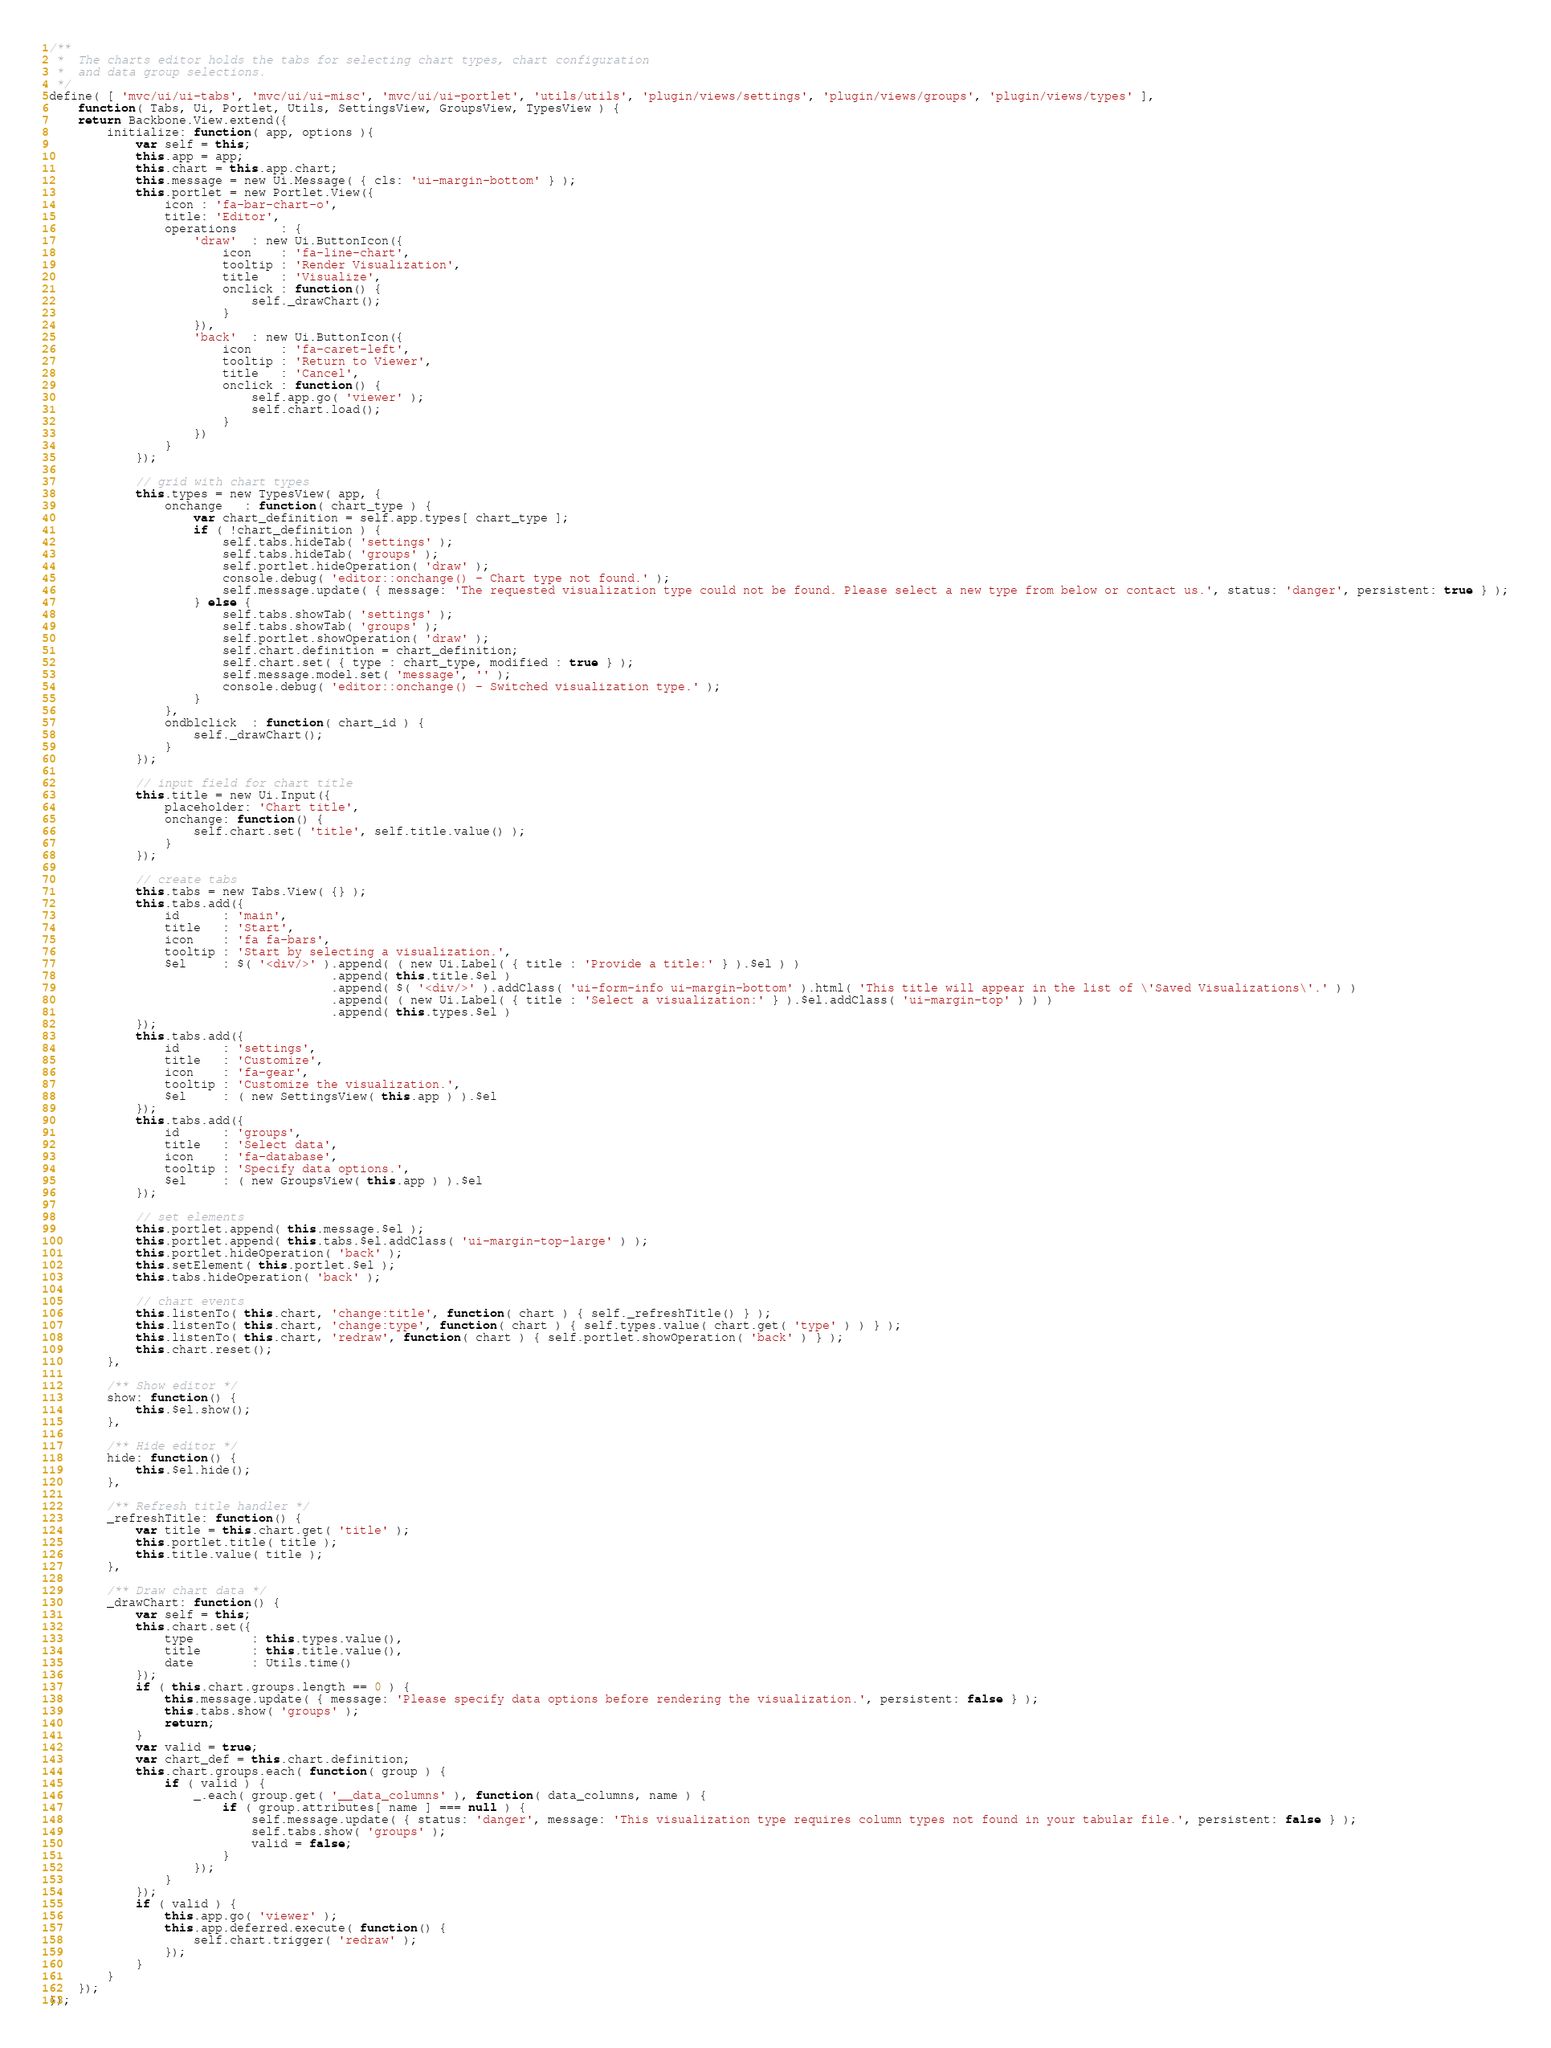<code> <loc_0><loc_0><loc_500><loc_500><_JavaScript_>/**
 *  The charts editor holds the tabs for selecting chart types, chart configuration
 *  and data group selections.
 */
define( [ 'mvc/ui/ui-tabs', 'mvc/ui/ui-misc', 'mvc/ui/ui-portlet', 'utils/utils', 'plugin/views/settings', 'plugin/views/groups', 'plugin/views/types' ],
    function( Tabs, Ui, Portlet, Utils, SettingsView, GroupsView, TypesView ) {
    return Backbone.View.extend({
        initialize: function( app, options ){
            var self = this;
            this.app = app;
            this.chart = this.app.chart;
            this.message = new Ui.Message( { cls: 'ui-margin-bottom' } );
            this.portlet = new Portlet.View({
                icon : 'fa-bar-chart-o',
                title: 'Editor',
                operations      : {
                    'draw'  : new Ui.ButtonIcon({
                        icon    : 'fa-line-chart',
                        tooltip : 'Render Visualization',
                        title   : 'Visualize',
                        onclick : function() {
                            self._drawChart();
                        }
                    }),
                    'back'  : new Ui.ButtonIcon({
                        icon    : 'fa-caret-left',
                        tooltip : 'Return to Viewer',
                        title   : 'Cancel',
                        onclick : function() {
                            self.app.go( 'viewer' );
                            self.chart.load();
                        }
                    })
                }
            });

            // grid with chart types
            this.types = new TypesView( app, {
                onchange   : function( chart_type ) {
                    var chart_definition = self.app.types[ chart_type ];
                    if ( !chart_definition ) {
                        self.tabs.hideTab( 'settings' );
                        self.tabs.hideTab( 'groups' );
                        self.portlet.hideOperation( 'draw' );
                        console.debug( 'editor::onchange() - Chart type not found.' );
                        self.message.update( { message: 'The requested visualization type could not be found. Please select a new type from below or contact us.', status: 'danger', persistent: true } );
                    } else {
                        self.tabs.showTab( 'settings' );
                        self.tabs.showTab( 'groups' );
                        self.portlet.showOperation( 'draw' );
                        self.chart.definition = chart_definition;
                        self.chart.set( { type : chart_type, modified : true } );
                        self.message.model.set( 'message', '' );
                        console.debug( 'editor::onchange() - Switched visualization type.' );
                    }
                },
                ondblclick  : function( chart_id ) {
                    self._drawChart();
                }
            });

            // input field for chart title
            this.title = new Ui.Input({
                placeholder: 'Chart title',
                onchange: function() {
                    self.chart.set( 'title', self.title.value() );
                }
            });

            // create tabs
            this.tabs = new Tabs.View( {} );
            this.tabs.add({
                id      : 'main',
                title   : 'Start',
                icon    : 'fa fa-bars',
                tooltip : 'Start by selecting a visualization.',
                $el     : $( '<div/>' ).append( ( new Ui.Label( { title : 'Provide a title:' } ).$el ) )
                                       .append( this.title.$el )
                                       .append( $( '<div/>' ).addClass( 'ui-form-info ui-margin-bottom' ).html( 'This title will appear in the list of \'Saved Visualizations\'.' ) )
                                       .append( ( new Ui.Label( { title : 'Select a visualization:' } ).$el.addClass( 'ui-margin-top' ) ) )
                                       .append( this.types.$el )
            });
            this.tabs.add({
                id      : 'settings',
                title   : 'Customize',
                icon    : 'fa-gear',
                tooltip : 'Customize the visualization.',
                $el     : ( new SettingsView( this.app ) ).$el
            });
            this.tabs.add({
                id      : 'groups',
                title   : 'Select data',
                icon    : 'fa-database',
                tooltip : 'Specify data options.',
                $el     : ( new GroupsView( this.app ) ).$el
            });

            // set elements
            this.portlet.append( this.message.$el );
            this.portlet.append( this.tabs.$el.addClass( 'ui-margin-top-large' ) );
            this.portlet.hideOperation( 'back' );
            this.setElement( this.portlet.$el );
            this.tabs.hideOperation( 'back' );

            // chart events
            this.listenTo( this.chart, 'change:title', function( chart ) { self._refreshTitle() } );
            this.listenTo( this.chart, 'change:type', function( chart ) { self.types.value( chart.get( 'type' ) ) } );
            this.listenTo( this.chart, 'redraw', function( chart ) { self.portlet.showOperation( 'back' ) } );
            this.chart.reset();
        },

        /** Show editor */
        show: function() {
            this.$el.show();
        },

        /** Hide editor */
        hide: function() {
            this.$el.hide();
        },

        /** Refresh title handler */
        _refreshTitle: function() {
            var title = this.chart.get( 'title' );
            this.portlet.title( title );
            this.title.value( title );
        },

        /** Draw chart data */
        _drawChart: function() {
            var self = this;
            this.chart.set({
                type        : this.types.value(),
                title       : this.title.value(),
                date        : Utils.time()
            });
            if ( this.chart.groups.length == 0 ) {
                this.message.update( { message: 'Please specify data options before rendering the visualization.', persistent: false } );
                this.tabs.show( 'groups' );
                return;
            }
            var valid = true;
            var chart_def = this.chart.definition;
            this.chart.groups.each( function( group ) {
                if ( valid ) {
                    _.each( group.get( '__data_columns' ), function( data_columns, name ) {
                        if ( group.attributes[ name ] === null ) {
                            self.message.update( { status: 'danger', message: 'This visualization type requires column types not found in your tabular file.', persistent: false } );
                            self.tabs.show( 'groups' );
                            valid = false;
                        }
                    });
                }
            });
            if ( valid ) {
                this.app.go( 'viewer' );
                this.app.deferred.execute( function() {
                    self.chart.trigger( 'redraw' );
                });
            }
        }
    });
});</code> 